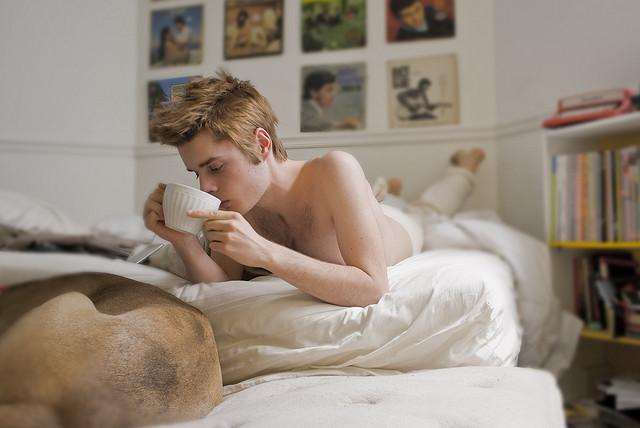What is this person holding?
Give a very brief answer. Cup. Is the person reclining?
Answer briefly. No. What is the man touching?
Short answer required. Cup. Is the man laying down?
Be succinct. Yes. Where is the other eye?
Concise answer only. Out of view. What is the dog doing on the couch?
Give a very brief answer. Sleeping. Are the walls decorated?
Answer briefly. Yes. What is hanging on the wall?
Give a very brief answer. Pictures. 